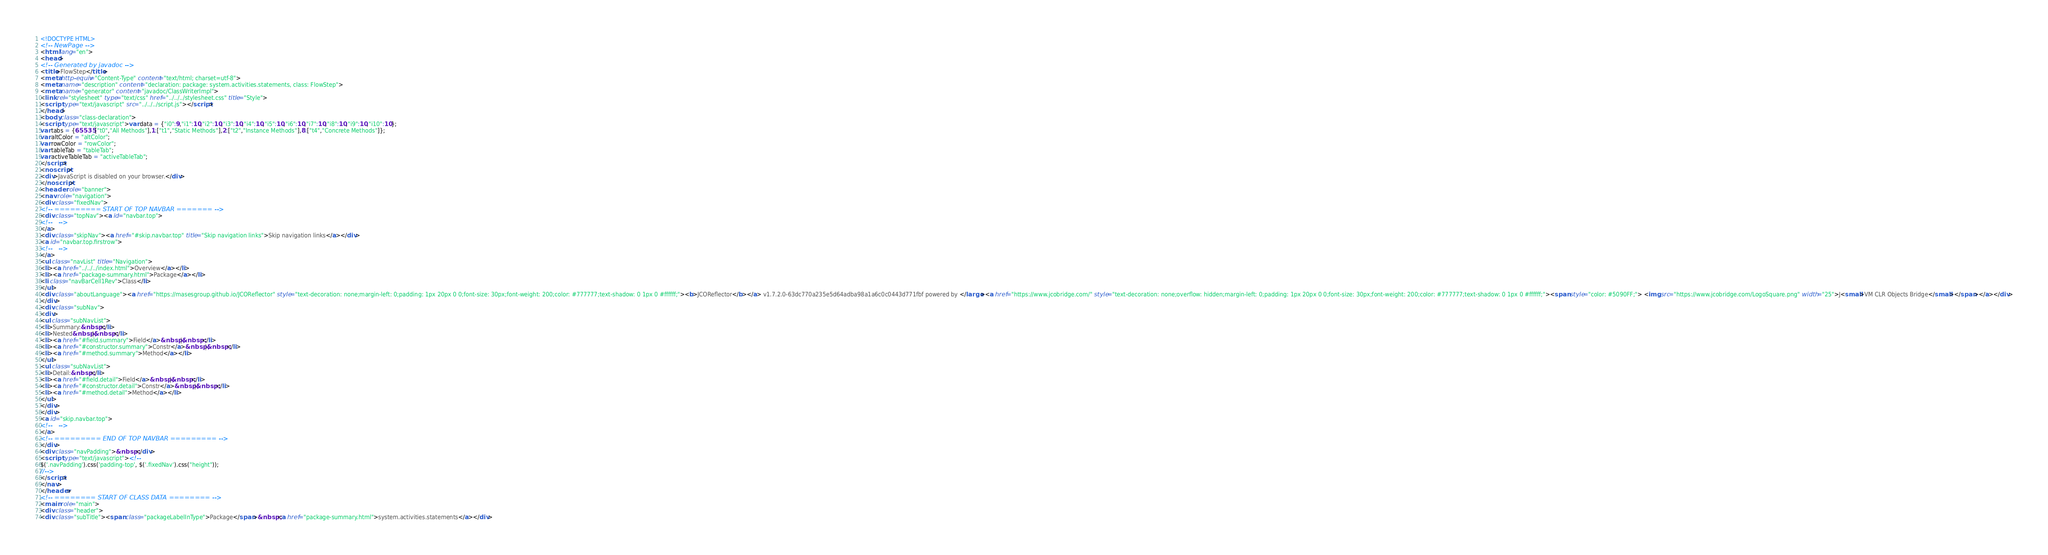Convert code to text. <code><loc_0><loc_0><loc_500><loc_500><_HTML_><!DOCTYPE HTML>
<!-- NewPage -->
<html lang="en">
<head>
<!-- Generated by javadoc -->
<title>FlowStep</title>
<meta http-equiv="Content-Type" content="text/html; charset=utf-8">
<meta name="description" content="declaration: package: system.activities.statements, class: FlowStep">
<meta name="generator" content="javadoc/ClassWriterImpl">
<link rel="stylesheet" type="text/css" href="../../../stylesheet.css" title="Style">
<script type="text/javascript" src="../../../script.js"></script>
</head>
<body class="class-declaration">
<script type="text/javascript">var data = {"i0":9,"i1":10,"i2":10,"i3":10,"i4":10,"i5":10,"i6":10,"i7":10,"i8":10,"i9":10,"i10":10};
var tabs = {65535:["t0","All Methods"],1:["t1","Static Methods"],2:["t2","Instance Methods"],8:["t4","Concrete Methods"]};
var altColor = "altColor";
var rowColor = "rowColor";
var tableTab = "tableTab";
var activeTableTab = "activeTableTab";
</script>
<noscript>
<div>JavaScript is disabled on your browser.</div>
</noscript>
<header role="banner">
<nav role="navigation">
<div class="fixedNav">
<!-- ========= START OF TOP NAVBAR ======= -->
<div class="topNav"><a id="navbar.top">
<!--   -->
</a>
<div class="skipNav"><a href="#skip.navbar.top" title="Skip navigation links">Skip navigation links</a></div>
<a id="navbar.top.firstrow">
<!--   -->
</a>
<ul class="navList" title="Navigation">
<li><a href="../../../index.html">Overview</a></li>
<li><a href="package-summary.html">Package</a></li>
<li class="navBarCell1Rev">Class</li>
</ul>
<div class="aboutLanguage"><a href="https://masesgroup.github.io/JCOReflector" style="text-decoration: none;margin-left: 0;padding: 1px 20px 0 0;font-size: 30px;font-weight: 200;color: #777777;text-shadow: 0 1px 0 #ffffff;"><b>JCOReflector</b></a> v1.7.2.0-63dc770a235e5d64adba98a1a6c0c0443d771fbf powered by </large><a href="https://www.jcobridge.com/" style="text-decoration: none;overflow: hidden;margin-left: 0;padding: 1px 20px 0 0;font-size: 30px;font-weight: 200;color: #777777;text-shadow: 0 1px 0 #ffffff;"><span style="color: #5090FF;"> <img src="https://www.jcobridge.com/LogoSquare.png" width="25">J<small>VM CLR Objects Bridge</small></span></a></div>
</div>
<div class="subNav">
<div>
<ul class="subNavList">
<li>Summary:&nbsp;</li>
<li>Nested&nbsp;|&nbsp;</li>
<li><a href="#field.summary">Field</a>&nbsp;|&nbsp;</li>
<li><a href="#constructor.summary">Constr</a>&nbsp;|&nbsp;</li>
<li><a href="#method.summary">Method</a></li>
</ul>
<ul class="subNavList">
<li>Detail:&nbsp;</li>
<li><a href="#field.detail">Field</a>&nbsp;|&nbsp;</li>
<li><a href="#constructor.detail">Constr</a>&nbsp;|&nbsp;</li>
<li><a href="#method.detail">Method</a></li>
</ul>
</div>
</div>
<a id="skip.navbar.top">
<!--   -->
</a>
<!-- ========= END OF TOP NAVBAR ========= -->
</div>
<div class="navPadding">&nbsp;</div>
<script type="text/javascript"><!--
$('.navPadding').css('padding-top', $('.fixedNav').css("height"));
//-->
</script>
</nav>
</header>
<!-- ======== START OF CLASS DATA ======== -->
<main role="main">
<div class="header">
<div class="subTitle"><span class="packageLabelInType">Package</span>&nbsp;<a href="package-summary.html">system.activities.statements</a></div></code> 